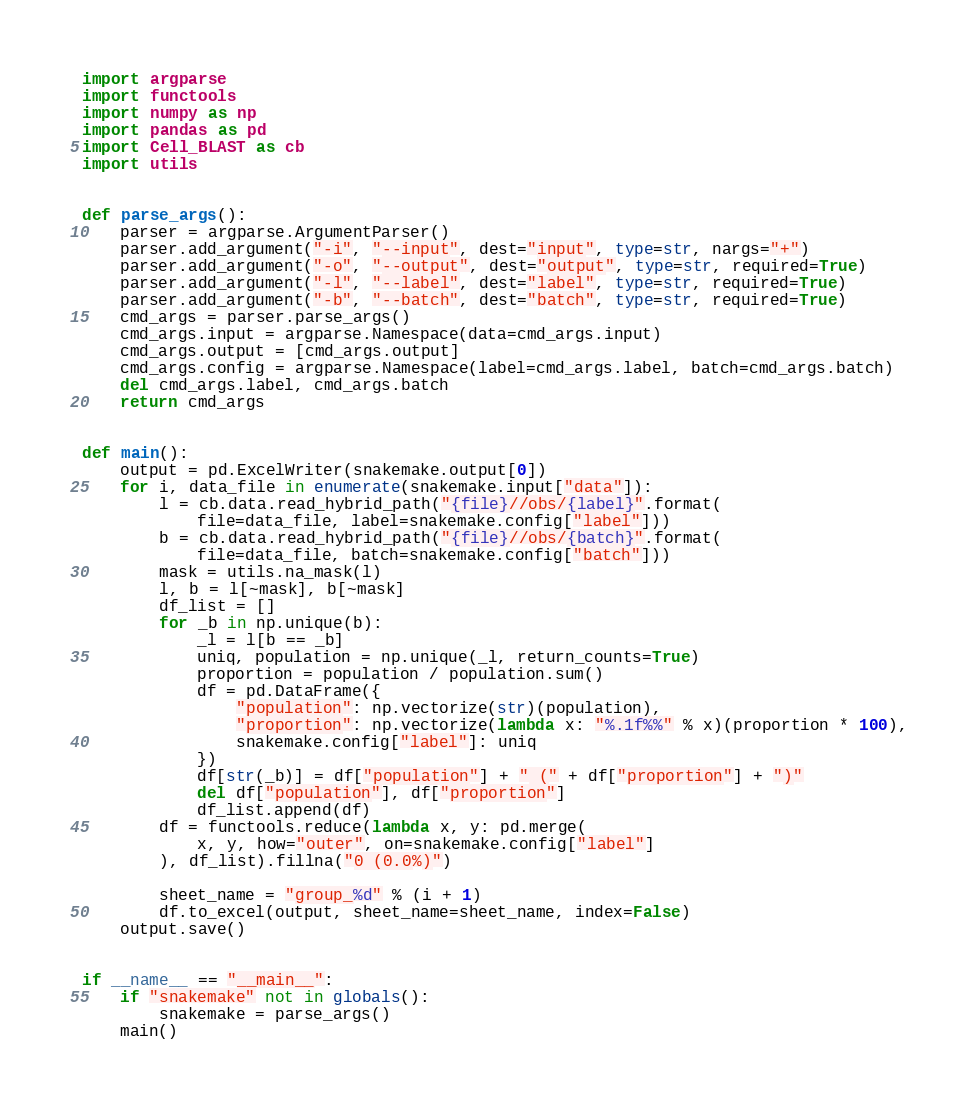Convert code to text. <code><loc_0><loc_0><loc_500><loc_500><_Python_>import argparse
import functools
import numpy as np
import pandas as pd
import Cell_BLAST as cb
import utils


def parse_args():
    parser = argparse.ArgumentParser()
    parser.add_argument("-i", "--input", dest="input", type=str, nargs="+")
    parser.add_argument("-o", "--output", dest="output", type=str, required=True)
    parser.add_argument("-l", "--label", dest="label", type=str, required=True)
    parser.add_argument("-b", "--batch", dest="batch", type=str, required=True)
    cmd_args = parser.parse_args()
    cmd_args.input = argparse.Namespace(data=cmd_args.input)
    cmd_args.output = [cmd_args.output]
    cmd_args.config = argparse.Namespace(label=cmd_args.label, batch=cmd_args.batch)
    del cmd_args.label, cmd_args.batch
    return cmd_args


def main():
    output = pd.ExcelWriter(snakemake.output[0])
    for i, data_file in enumerate(snakemake.input["data"]):
        l = cb.data.read_hybrid_path("{file}//obs/{label}".format(
            file=data_file, label=snakemake.config["label"]))
        b = cb.data.read_hybrid_path("{file}//obs/{batch}".format(
            file=data_file, batch=snakemake.config["batch"]))
        mask = utils.na_mask(l)
        l, b = l[~mask], b[~mask]
        df_list = []
        for _b in np.unique(b):
            _l = l[b == _b]
            uniq, population = np.unique(_l, return_counts=True)
            proportion = population / population.sum()
            df = pd.DataFrame({
                "population": np.vectorize(str)(population),
                "proportion": np.vectorize(lambda x: "%.1f%%" % x)(proportion * 100),
                snakemake.config["label"]: uniq
            })
            df[str(_b)] = df["population"] + " (" + df["proportion"] + ")"
            del df["population"], df["proportion"]
            df_list.append(df)
        df = functools.reduce(lambda x, y: pd.merge(
            x, y, how="outer", on=snakemake.config["label"]
        ), df_list).fillna("0 (0.0%)")

        sheet_name = "group_%d" % (i + 1)
        df.to_excel(output, sheet_name=sheet_name, index=False)
    output.save()


if __name__ == "__main__":
    if "snakemake" not in globals():
        snakemake = parse_args()
    main()
</code> 